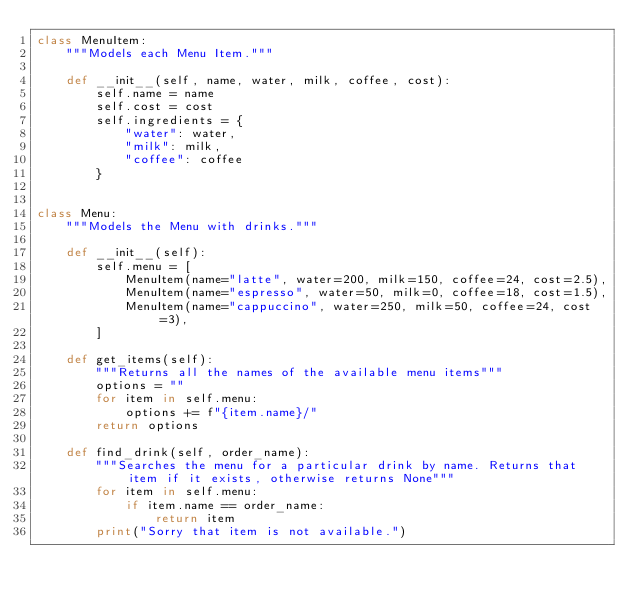Convert code to text. <code><loc_0><loc_0><loc_500><loc_500><_Python_>class MenuItem:
    """Models each Menu Item."""

    def __init__(self, name, water, milk, coffee, cost):
        self.name = name
        self.cost = cost
        self.ingredients = {
            "water": water,
            "milk": milk,
            "coffee": coffee
        }


class Menu:
    """Models the Menu with drinks."""

    def __init__(self):
        self.menu = [
            MenuItem(name="latte", water=200, milk=150, coffee=24, cost=2.5),
            MenuItem(name="espresso", water=50, milk=0, coffee=18, cost=1.5),
            MenuItem(name="cappuccino", water=250, milk=50, coffee=24, cost=3),
        ]

    def get_items(self):
        """Returns all the names of the available menu items"""
        options = ""
        for item in self.menu:
            options += f"{item.name}/"
        return options

    def find_drink(self, order_name):
        """Searches the menu for a particular drink by name. Returns that item if it exists, otherwise returns None"""
        for item in self.menu:
            if item.name == order_name:
                return item
        print("Sorry that item is not available.")
</code> 